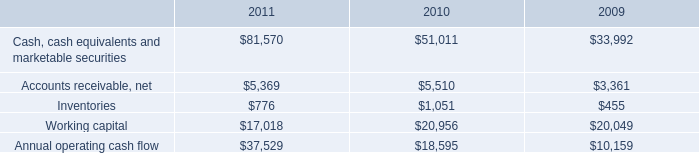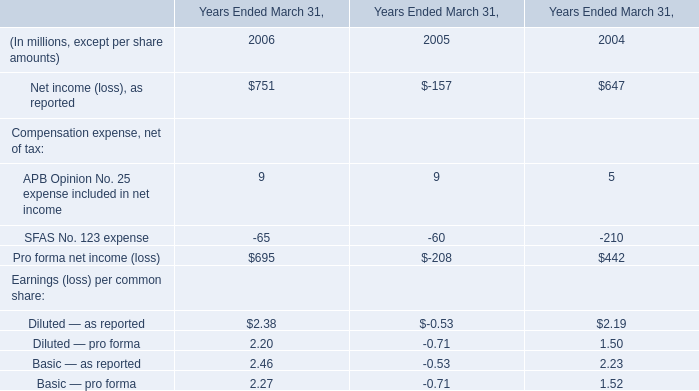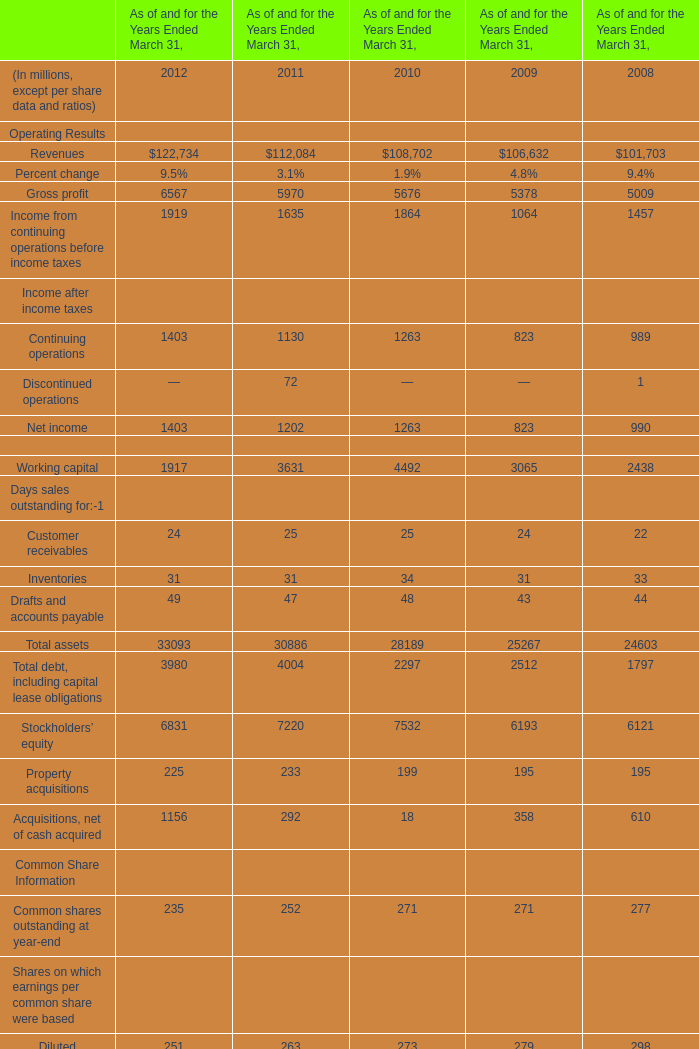What is the growing rate of Property acquisitions in the year with the most Income from continuing operations before income taxes the most? 
Computations: ((225 - 233) / 225)
Answer: -0.03556. 